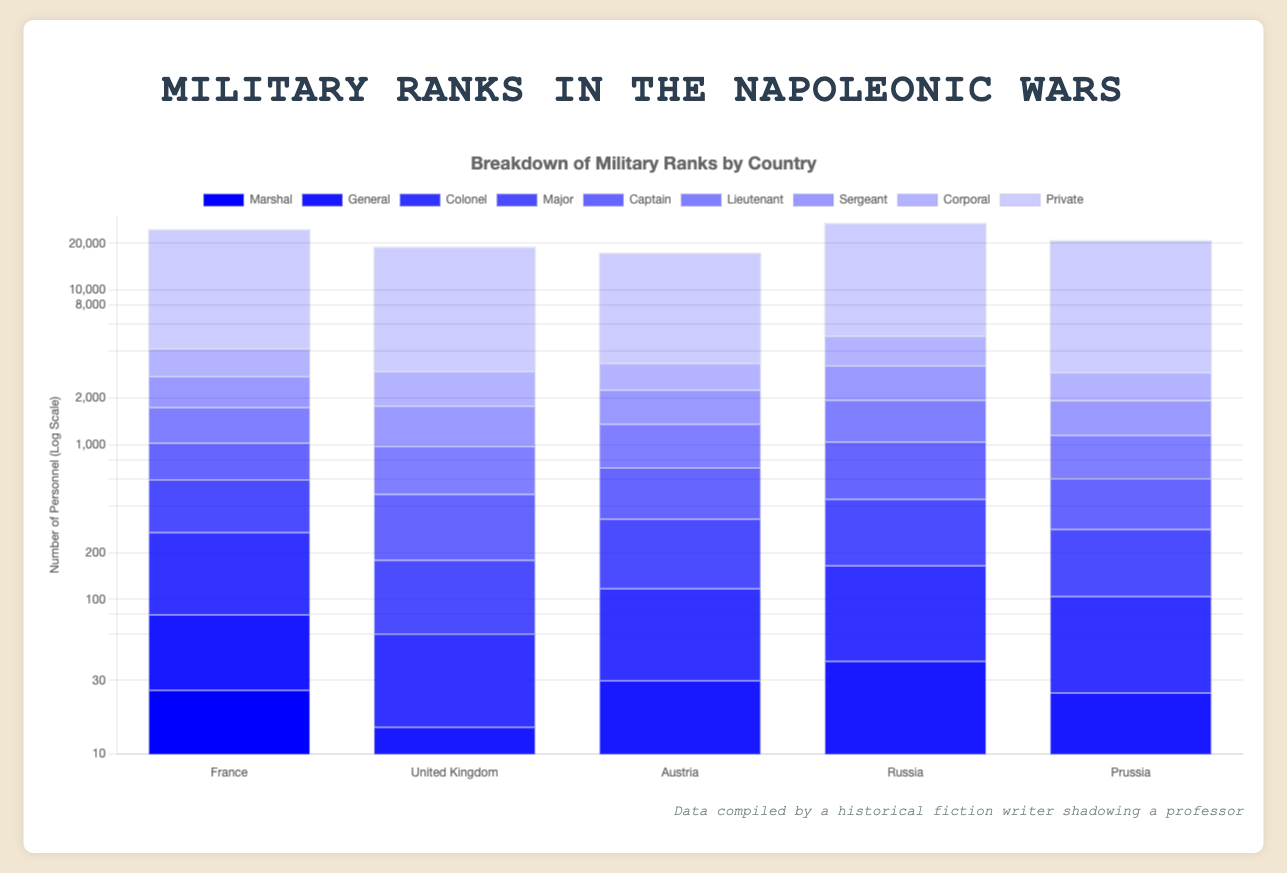Which country has the highest number of Privates? The chart shows the number of personnel for each rank by country. Looking at the "Private" rank, we can see that Russia has the highest number with 22,000 Privates.
Answer: Russia Which rank has the fewest personnel across all countries? By comparing the personnel numbers for all ranks across all countries, we see that Austria's "Generalissimus" rank has the fewest personnel with just 1.
Answer: Generalissimus Which country has more Captains, France or Prussia? France has 432 Captains, whereas Prussia has 320 Captains. Therefore, France has more Captains than Prussia.
Answer: France Which rank sees the largest difference in personnel between France and the United Kingdom? To find the largest difference, subtract the personnel numbers of the United Kingdom from those of France for each rank. The "Private" rank shows the biggest difference: 20,480 (France) - 16,000 (United Kingdom) = 4,480.
Answer: Private What is the total number of Generals across all countries? Add up the number of Generals listed for each country: 54 (France) + 15 (United Kingdom) + 30 (Austria) + 40 (Russia) + 25 (Prussia) = 164.
Answer: 164 Which rank has the steadiest (most even) distribution across all countries? Comparing the personnel numbers of each rank across all countries, "Private" seems the steadiest as each country has a high number but with relatively smaller differences compared to total numbers: France (20,480), United Kingdom (16,000), Austria (14,000), Russia (22,000), and Prussia (18,000).
Answer: Private Which country has the lowest number of Majors, and what is the number? By referring to the chart, the United Kingdom has the lowest number of Majors with only 120 personnel.
Answer: United Kingdom - 120 How many more Lieutenants does Russia have compared to France? To find the difference, subtract the number of Lieutenants in France from the number of Lieutenants in Russia: 900 (Russia) - 720 (France) = 180.
Answer: 180 